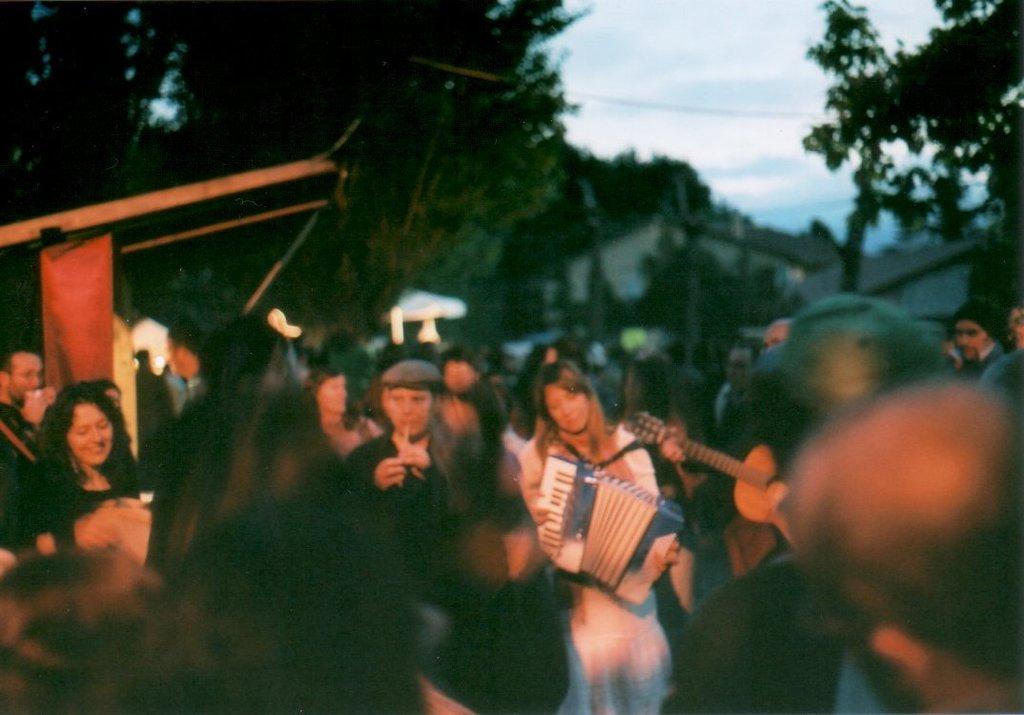Please provide a concise description of this image. In this image i can see a number of persons playing a music a and back side of them there is a tree and there is a sky visible. 